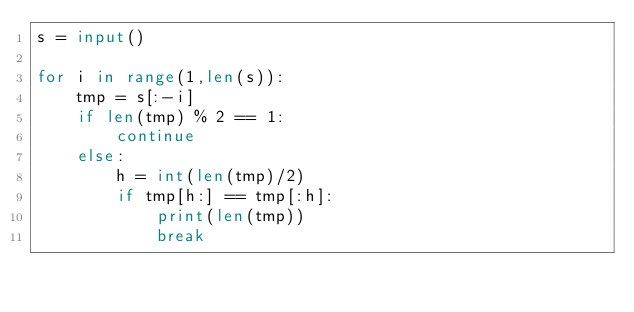<code> <loc_0><loc_0><loc_500><loc_500><_Python_>s = input()

for i in range(1,len(s)):
    tmp = s[:-i]
    if len(tmp) % 2 == 1:
        continue
    else:
        h = int(len(tmp)/2)
        if tmp[h:] == tmp[:h]:
            print(len(tmp))
            break</code> 